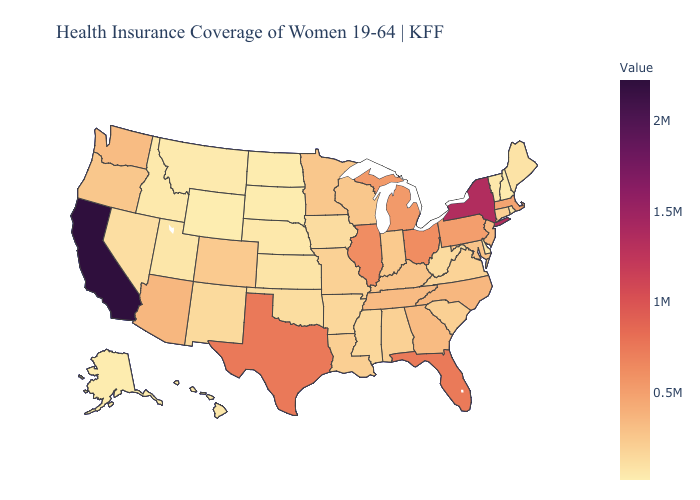Among the states that border New Jersey , does Delaware have the highest value?
Answer briefly. No. Does New Hampshire have the lowest value in the Northeast?
Keep it brief. Yes. Among the states that border Massachusetts , which have the lowest value?
Keep it brief. New Hampshire. Which states have the lowest value in the USA?
Concise answer only. Wyoming. Which states have the lowest value in the South?
Concise answer only. Delaware. Does Delaware have the lowest value in the South?
Write a very short answer. Yes. 